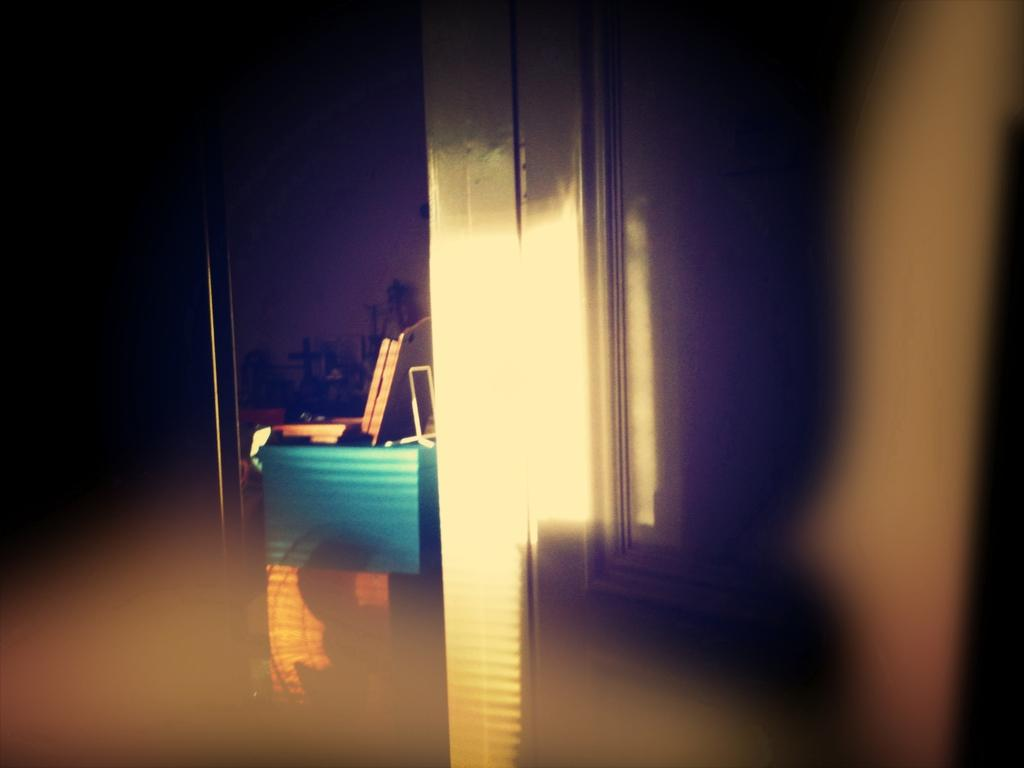What is located beside the wall in the image? There is an object beside the wall in the image. What type of pan is being used for cooking in the image? There is no pan present in the image; only an object beside the wall is mentioned. 